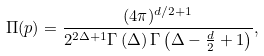Convert formula to latex. <formula><loc_0><loc_0><loc_500><loc_500>\Pi ( p ) = \frac { ( 4 \pi ) ^ { d / 2 + 1 } } { 2 ^ { 2 \Delta + 1 } \Gamma \left ( \Delta \right ) \Gamma \left ( \Delta - \frac { d } { 2 } + 1 \right ) } ,</formula> 